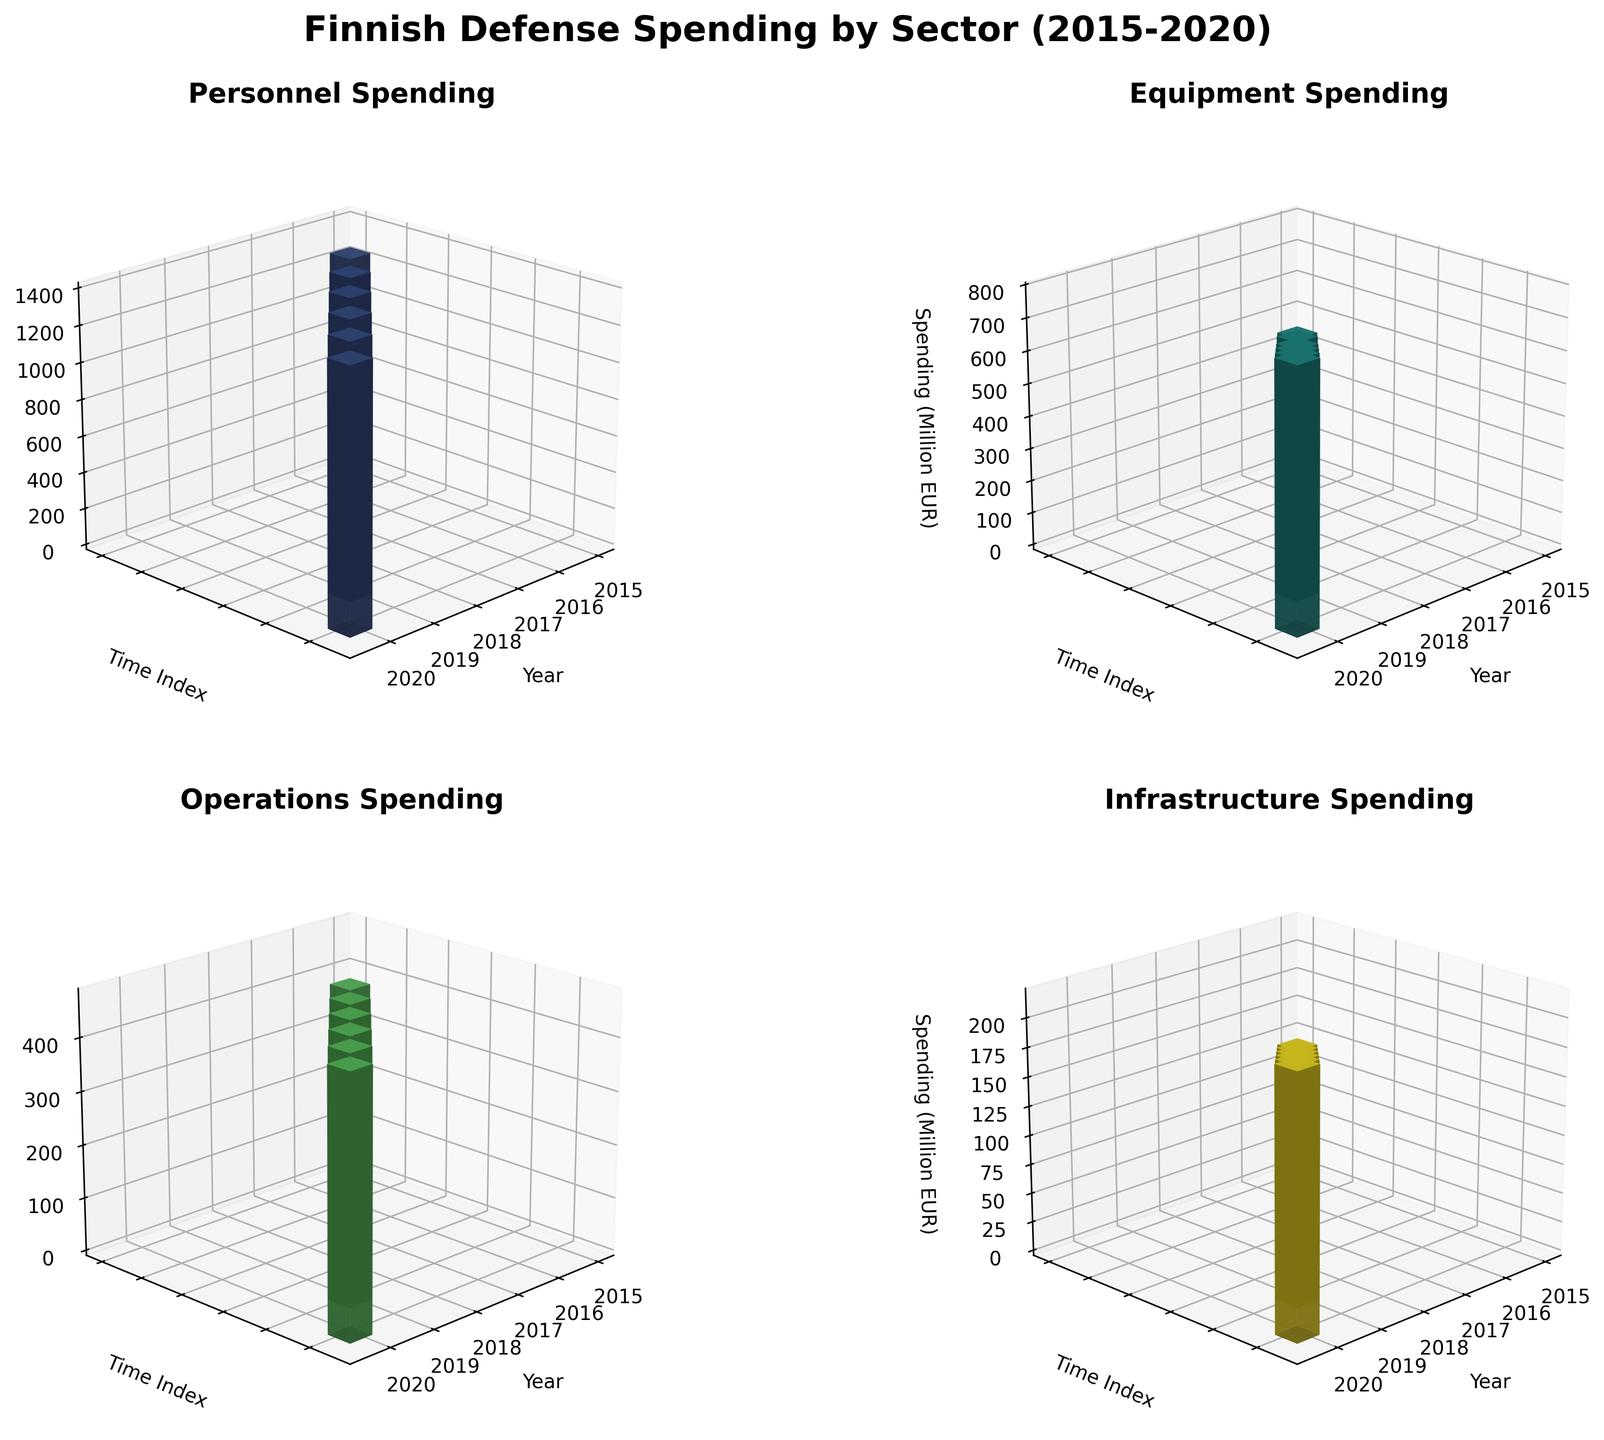What is the title of the overall figure? The title is located at the top of the figure and typically indicates the main subject or focus of the data presented.
Answer: Finnish Defense Spending by Sector (2015-2020) Which sector has the highest spending in 2020? Examine the z-axis values of each subplot for the year 2020 and identify which one is the tallest bar. The highest bar represents the sector with the highest spending.
Answer: Personnel How many different sectors are displayed in the figure? Count the number of subplots, each representing a different sector, in the figure.
Answer: 4 Which year saw the biggest increase in Equipment spending compared to the previous year? Compare the height of the bars for Equipment spending for all adjacent years, and find the pair with the largest difference.
Answer: 2015 to 2016 Arrange the sectors in decreasing order of spending in 2019. For the year 2019, order the sectors by the height of their respective bars from tallest to shortest.
Answer: Personnel, Equipment, Operations, Infrastructure What is the total defense spending across all sectors in 2018? Sum the spending (z-axis values) of all the sectors for the year 2018.
Answer: 2610 Million EUR Which sector experienced a continuous increase in spending from 2015 to 2020? Check all the subplots to identify which sector’s spending bar (z-axis) increases for each consecutive year.
Answer: All sectors How many years are represented in the figure? Count the number of distinct ticks or labels along the x-axis, which indicates the different years plotted.
Answer: 6 Which sector showed the least variation in spending between the years 2015 and 2020? Examine the height (z-values) of the bars over the six years for each sector, and determine which sector has bars of similar height.
Answer: Operations By how much did Infrastructure spending increase from 2017 to 2019? Find the height of the bars for Infrastructure spending in 2017 and 2019, then subtract the 2017 value from 2019 to get the increase.
Answer: 40 Million EUR 